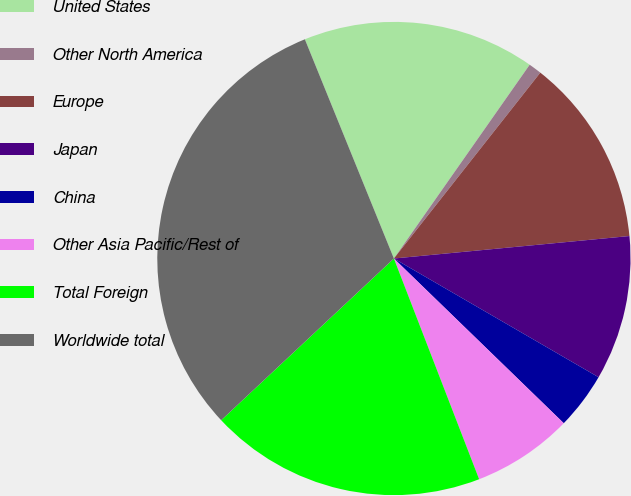Convert chart to OTSL. <chart><loc_0><loc_0><loc_500><loc_500><pie_chart><fcel>United States<fcel>Other North America<fcel>Europe<fcel>Japan<fcel>China<fcel>Other Asia Pacific/Rest of<fcel>Total Foreign<fcel>Worldwide total<nl><fcel>15.87%<fcel>0.89%<fcel>12.87%<fcel>9.88%<fcel>3.89%<fcel>6.88%<fcel>18.89%<fcel>30.84%<nl></chart> 